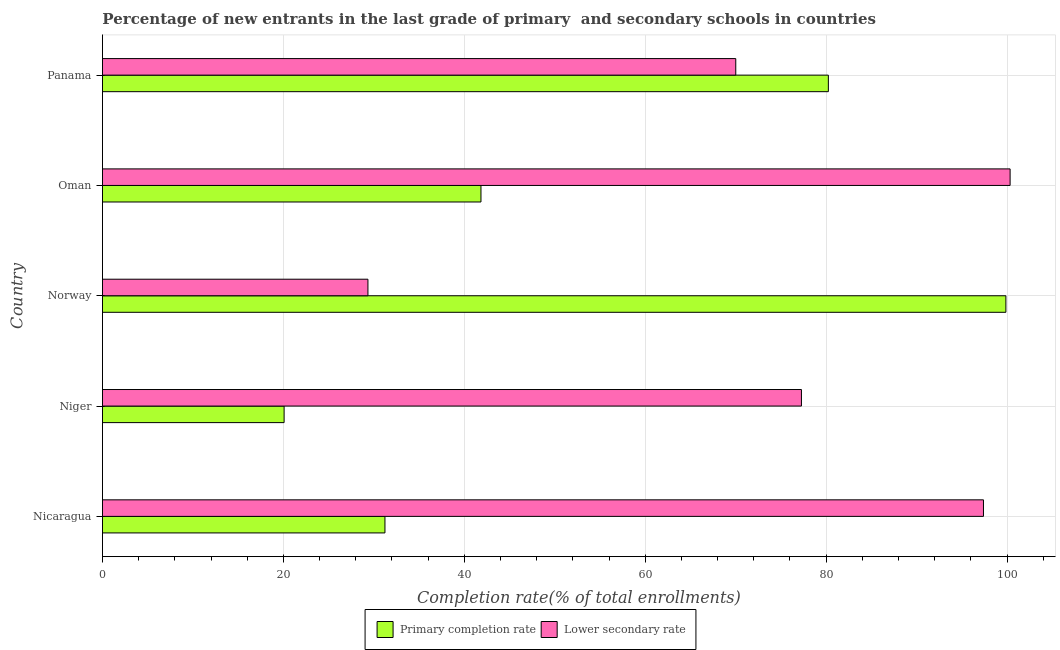How many groups of bars are there?
Provide a succinct answer. 5. Are the number of bars per tick equal to the number of legend labels?
Give a very brief answer. Yes. Are the number of bars on each tick of the Y-axis equal?
Provide a short and direct response. Yes. How many bars are there on the 1st tick from the top?
Offer a very short reply. 2. How many bars are there on the 1st tick from the bottom?
Your answer should be compact. 2. What is the label of the 5th group of bars from the top?
Your answer should be very brief. Nicaragua. What is the completion rate in secondary schools in Nicaragua?
Offer a terse response. 97.39. Across all countries, what is the maximum completion rate in primary schools?
Your answer should be compact. 99.87. Across all countries, what is the minimum completion rate in secondary schools?
Make the answer very short. 29.35. In which country was the completion rate in secondary schools minimum?
Give a very brief answer. Norway. What is the total completion rate in secondary schools in the graph?
Your response must be concise. 374.36. What is the difference between the completion rate in secondary schools in Norway and that in Panama?
Keep it short and to the point. -40.66. What is the difference between the completion rate in primary schools in Nicaragua and the completion rate in secondary schools in Oman?
Keep it short and to the point. -69.11. What is the average completion rate in primary schools per country?
Provide a succinct answer. 54.65. What is the difference between the completion rate in secondary schools and completion rate in primary schools in Nicaragua?
Your answer should be very brief. 66.16. In how many countries, is the completion rate in secondary schools greater than 76 %?
Give a very brief answer. 3. What is the ratio of the completion rate in primary schools in Oman to that in Panama?
Your response must be concise. 0.52. Is the completion rate in secondary schools in Nicaragua less than that in Norway?
Provide a succinct answer. No. What is the difference between the highest and the second highest completion rate in primary schools?
Make the answer very short. 19.63. What is the difference between the highest and the lowest completion rate in primary schools?
Offer a very short reply. 79.79. What does the 2nd bar from the top in Oman represents?
Give a very brief answer. Primary completion rate. What does the 2nd bar from the bottom in Niger represents?
Your response must be concise. Lower secondary rate. How many bars are there?
Provide a succinct answer. 10. How many countries are there in the graph?
Offer a terse response. 5. What is the difference between two consecutive major ticks on the X-axis?
Make the answer very short. 20. Does the graph contain grids?
Give a very brief answer. Yes. How many legend labels are there?
Your answer should be very brief. 2. How are the legend labels stacked?
Keep it short and to the point. Horizontal. What is the title of the graph?
Ensure brevity in your answer.  Percentage of new entrants in the last grade of primary  and secondary schools in countries. Does "From Government" appear as one of the legend labels in the graph?
Give a very brief answer. No. What is the label or title of the X-axis?
Offer a very short reply. Completion rate(% of total enrollments). What is the label or title of the Y-axis?
Ensure brevity in your answer.  Country. What is the Completion rate(% of total enrollments) in Primary completion rate in Nicaragua?
Your answer should be very brief. 31.23. What is the Completion rate(% of total enrollments) in Lower secondary rate in Nicaragua?
Give a very brief answer. 97.39. What is the Completion rate(% of total enrollments) of Primary completion rate in Niger?
Your answer should be very brief. 20.08. What is the Completion rate(% of total enrollments) in Lower secondary rate in Niger?
Provide a short and direct response. 77.27. What is the Completion rate(% of total enrollments) of Primary completion rate in Norway?
Your answer should be compact. 99.87. What is the Completion rate(% of total enrollments) of Lower secondary rate in Norway?
Your answer should be compact. 29.35. What is the Completion rate(% of total enrollments) in Primary completion rate in Oman?
Keep it short and to the point. 41.84. What is the Completion rate(% of total enrollments) of Lower secondary rate in Oman?
Give a very brief answer. 100.34. What is the Completion rate(% of total enrollments) of Primary completion rate in Panama?
Provide a short and direct response. 80.25. What is the Completion rate(% of total enrollments) of Lower secondary rate in Panama?
Make the answer very short. 70.01. Across all countries, what is the maximum Completion rate(% of total enrollments) in Primary completion rate?
Give a very brief answer. 99.87. Across all countries, what is the maximum Completion rate(% of total enrollments) of Lower secondary rate?
Make the answer very short. 100.34. Across all countries, what is the minimum Completion rate(% of total enrollments) of Primary completion rate?
Give a very brief answer. 20.08. Across all countries, what is the minimum Completion rate(% of total enrollments) of Lower secondary rate?
Your response must be concise. 29.35. What is the total Completion rate(% of total enrollments) in Primary completion rate in the graph?
Provide a succinct answer. 273.27. What is the total Completion rate(% of total enrollments) of Lower secondary rate in the graph?
Your answer should be compact. 374.36. What is the difference between the Completion rate(% of total enrollments) in Primary completion rate in Nicaragua and that in Niger?
Ensure brevity in your answer.  11.15. What is the difference between the Completion rate(% of total enrollments) in Lower secondary rate in Nicaragua and that in Niger?
Give a very brief answer. 20.12. What is the difference between the Completion rate(% of total enrollments) in Primary completion rate in Nicaragua and that in Norway?
Provide a short and direct response. -68.64. What is the difference between the Completion rate(% of total enrollments) of Lower secondary rate in Nicaragua and that in Norway?
Provide a succinct answer. 68.05. What is the difference between the Completion rate(% of total enrollments) in Primary completion rate in Nicaragua and that in Oman?
Provide a succinct answer. -10.61. What is the difference between the Completion rate(% of total enrollments) in Lower secondary rate in Nicaragua and that in Oman?
Keep it short and to the point. -2.95. What is the difference between the Completion rate(% of total enrollments) in Primary completion rate in Nicaragua and that in Panama?
Offer a terse response. -49.02. What is the difference between the Completion rate(% of total enrollments) in Lower secondary rate in Nicaragua and that in Panama?
Offer a terse response. 27.38. What is the difference between the Completion rate(% of total enrollments) of Primary completion rate in Niger and that in Norway?
Your response must be concise. -79.79. What is the difference between the Completion rate(% of total enrollments) in Lower secondary rate in Niger and that in Norway?
Make the answer very short. 47.92. What is the difference between the Completion rate(% of total enrollments) in Primary completion rate in Niger and that in Oman?
Provide a succinct answer. -21.76. What is the difference between the Completion rate(% of total enrollments) in Lower secondary rate in Niger and that in Oman?
Offer a terse response. -23.07. What is the difference between the Completion rate(% of total enrollments) of Primary completion rate in Niger and that in Panama?
Your answer should be very brief. -60.17. What is the difference between the Completion rate(% of total enrollments) in Lower secondary rate in Niger and that in Panama?
Your answer should be compact. 7.26. What is the difference between the Completion rate(% of total enrollments) of Primary completion rate in Norway and that in Oman?
Give a very brief answer. 58.03. What is the difference between the Completion rate(% of total enrollments) of Lower secondary rate in Norway and that in Oman?
Your answer should be compact. -70.99. What is the difference between the Completion rate(% of total enrollments) in Primary completion rate in Norway and that in Panama?
Offer a terse response. 19.63. What is the difference between the Completion rate(% of total enrollments) in Lower secondary rate in Norway and that in Panama?
Ensure brevity in your answer.  -40.66. What is the difference between the Completion rate(% of total enrollments) of Primary completion rate in Oman and that in Panama?
Keep it short and to the point. -38.4. What is the difference between the Completion rate(% of total enrollments) in Lower secondary rate in Oman and that in Panama?
Provide a short and direct response. 30.33. What is the difference between the Completion rate(% of total enrollments) of Primary completion rate in Nicaragua and the Completion rate(% of total enrollments) of Lower secondary rate in Niger?
Provide a short and direct response. -46.04. What is the difference between the Completion rate(% of total enrollments) of Primary completion rate in Nicaragua and the Completion rate(% of total enrollments) of Lower secondary rate in Norway?
Your answer should be very brief. 1.88. What is the difference between the Completion rate(% of total enrollments) of Primary completion rate in Nicaragua and the Completion rate(% of total enrollments) of Lower secondary rate in Oman?
Your answer should be very brief. -69.11. What is the difference between the Completion rate(% of total enrollments) in Primary completion rate in Nicaragua and the Completion rate(% of total enrollments) in Lower secondary rate in Panama?
Ensure brevity in your answer.  -38.78. What is the difference between the Completion rate(% of total enrollments) of Primary completion rate in Niger and the Completion rate(% of total enrollments) of Lower secondary rate in Norway?
Keep it short and to the point. -9.27. What is the difference between the Completion rate(% of total enrollments) in Primary completion rate in Niger and the Completion rate(% of total enrollments) in Lower secondary rate in Oman?
Ensure brevity in your answer.  -80.26. What is the difference between the Completion rate(% of total enrollments) in Primary completion rate in Niger and the Completion rate(% of total enrollments) in Lower secondary rate in Panama?
Give a very brief answer. -49.93. What is the difference between the Completion rate(% of total enrollments) of Primary completion rate in Norway and the Completion rate(% of total enrollments) of Lower secondary rate in Oman?
Your answer should be very brief. -0.47. What is the difference between the Completion rate(% of total enrollments) in Primary completion rate in Norway and the Completion rate(% of total enrollments) in Lower secondary rate in Panama?
Give a very brief answer. 29.86. What is the difference between the Completion rate(% of total enrollments) of Primary completion rate in Oman and the Completion rate(% of total enrollments) of Lower secondary rate in Panama?
Provide a succinct answer. -28.17. What is the average Completion rate(% of total enrollments) in Primary completion rate per country?
Offer a very short reply. 54.65. What is the average Completion rate(% of total enrollments) in Lower secondary rate per country?
Provide a short and direct response. 74.87. What is the difference between the Completion rate(% of total enrollments) in Primary completion rate and Completion rate(% of total enrollments) in Lower secondary rate in Nicaragua?
Give a very brief answer. -66.16. What is the difference between the Completion rate(% of total enrollments) in Primary completion rate and Completion rate(% of total enrollments) in Lower secondary rate in Niger?
Provide a succinct answer. -57.19. What is the difference between the Completion rate(% of total enrollments) in Primary completion rate and Completion rate(% of total enrollments) in Lower secondary rate in Norway?
Your answer should be compact. 70.53. What is the difference between the Completion rate(% of total enrollments) of Primary completion rate and Completion rate(% of total enrollments) of Lower secondary rate in Oman?
Give a very brief answer. -58.5. What is the difference between the Completion rate(% of total enrollments) of Primary completion rate and Completion rate(% of total enrollments) of Lower secondary rate in Panama?
Give a very brief answer. 10.24. What is the ratio of the Completion rate(% of total enrollments) in Primary completion rate in Nicaragua to that in Niger?
Make the answer very short. 1.56. What is the ratio of the Completion rate(% of total enrollments) of Lower secondary rate in Nicaragua to that in Niger?
Ensure brevity in your answer.  1.26. What is the ratio of the Completion rate(% of total enrollments) of Primary completion rate in Nicaragua to that in Norway?
Offer a terse response. 0.31. What is the ratio of the Completion rate(% of total enrollments) in Lower secondary rate in Nicaragua to that in Norway?
Ensure brevity in your answer.  3.32. What is the ratio of the Completion rate(% of total enrollments) in Primary completion rate in Nicaragua to that in Oman?
Provide a succinct answer. 0.75. What is the ratio of the Completion rate(% of total enrollments) in Lower secondary rate in Nicaragua to that in Oman?
Offer a terse response. 0.97. What is the ratio of the Completion rate(% of total enrollments) of Primary completion rate in Nicaragua to that in Panama?
Your answer should be compact. 0.39. What is the ratio of the Completion rate(% of total enrollments) of Lower secondary rate in Nicaragua to that in Panama?
Offer a terse response. 1.39. What is the ratio of the Completion rate(% of total enrollments) in Primary completion rate in Niger to that in Norway?
Ensure brevity in your answer.  0.2. What is the ratio of the Completion rate(% of total enrollments) of Lower secondary rate in Niger to that in Norway?
Ensure brevity in your answer.  2.63. What is the ratio of the Completion rate(% of total enrollments) in Primary completion rate in Niger to that in Oman?
Your response must be concise. 0.48. What is the ratio of the Completion rate(% of total enrollments) of Lower secondary rate in Niger to that in Oman?
Provide a short and direct response. 0.77. What is the ratio of the Completion rate(% of total enrollments) of Primary completion rate in Niger to that in Panama?
Give a very brief answer. 0.25. What is the ratio of the Completion rate(% of total enrollments) of Lower secondary rate in Niger to that in Panama?
Make the answer very short. 1.1. What is the ratio of the Completion rate(% of total enrollments) of Primary completion rate in Norway to that in Oman?
Provide a short and direct response. 2.39. What is the ratio of the Completion rate(% of total enrollments) of Lower secondary rate in Norway to that in Oman?
Give a very brief answer. 0.29. What is the ratio of the Completion rate(% of total enrollments) in Primary completion rate in Norway to that in Panama?
Make the answer very short. 1.24. What is the ratio of the Completion rate(% of total enrollments) of Lower secondary rate in Norway to that in Panama?
Your response must be concise. 0.42. What is the ratio of the Completion rate(% of total enrollments) in Primary completion rate in Oman to that in Panama?
Make the answer very short. 0.52. What is the ratio of the Completion rate(% of total enrollments) in Lower secondary rate in Oman to that in Panama?
Offer a very short reply. 1.43. What is the difference between the highest and the second highest Completion rate(% of total enrollments) of Primary completion rate?
Give a very brief answer. 19.63. What is the difference between the highest and the second highest Completion rate(% of total enrollments) of Lower secondary rate?
Provide a succinct answer. 2.95. What is the difference between the highest and the lowest Completion rate(% of total enrollments) of Primary completion rate?
Your answer should be compact. 79.79. What is the difference between the highest and the lowest Completion rate(% of total enrollments) of Lower secondary rate?
Your answer should be very brief. 70.99. 